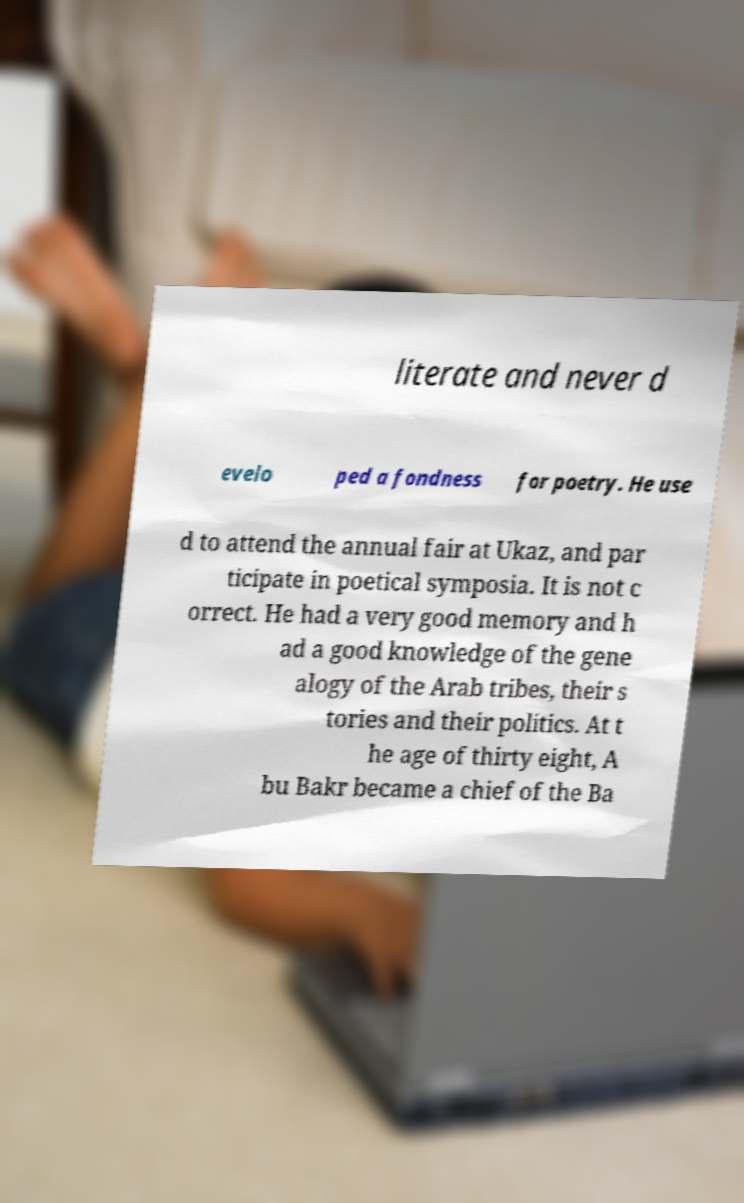Please identify and transcribe the text found in this image. literate and never d evelo ped a fondness for poetry. He use d to attend the annual fair at Ukaz, and par ticipate in poetical symposia. It is not c orrect. He had a very good memory and h ad a good knowledge of the gene alogy of the Arab tribes, their s tories and their politics. At t he age of thirty eight, A bu Bakr became a chief of the Ba 